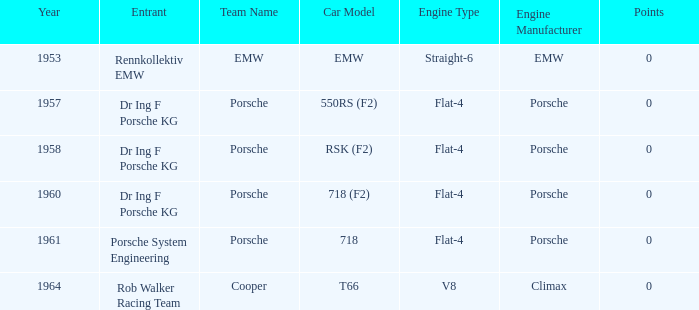Help me parse the entirety of this table. {'header': ['Year', 'Entrant', 'Team Name', 'Car Model', 'Engine Type', 'Engine Manufacturer', 'Points'], 'rows': [['1953', 'Rennkollektiv EMW', 'EMW', 'EMW', 'Straight-6', 'EMW', '0'], ['1957', 'Dr Ing F Porsche KG', 'Porsche', '550RS (F2)', 'Flat-4', 'Porsche', '0'], ['1958', 'Dr Ing F Porsche KG', 'Porsche', 'RSK (F2)', 'Flat-4', 'Porsche', '0'], ['1960', 'Dr Ing F Porsche KG', 'Porsche', '718 (F2)', 'Flat-4', 'Porsche', '0'], ['1961', 'Porsche System Engineering', 'Porsche', '718', 'Flat-4', 'Porsche', '0'], ['1964', 'Rob Walker Racing Team', 'Cooper', 'T66', 'V8', 'Climax', '0']]} Which year had more than 0 points? 0.0. 